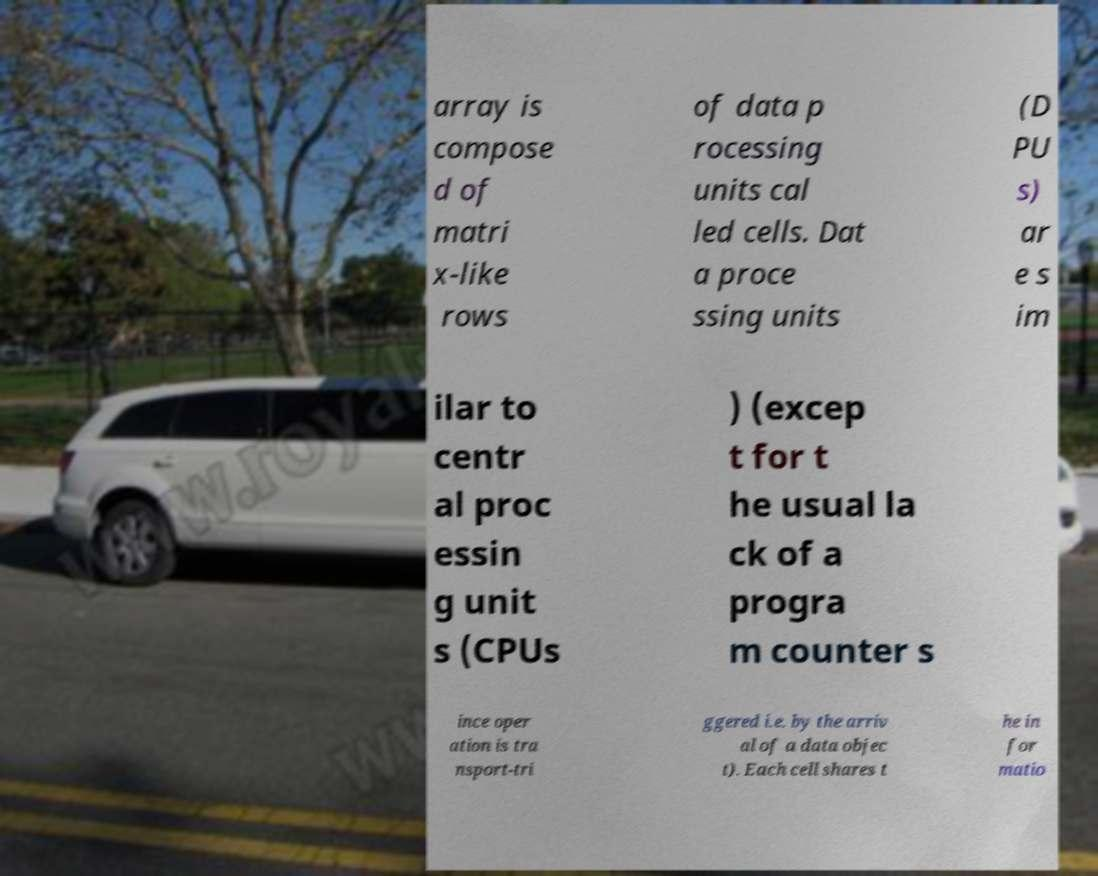Can you accurately transcribe the text from the provided image for me? array is compose d of matri x-like rows of data p rocessing units cal led cells. Dat a proce ssing units (D PU s) ar e s im ilar to centr al proc essin g unit s (CPUs ) (excep t for t he usual la ck of a progra m counter s ince oper ation is tra nsport-tri ggered i.e. by the arriv al of a data objec t). Each cell shares t he in for matio 